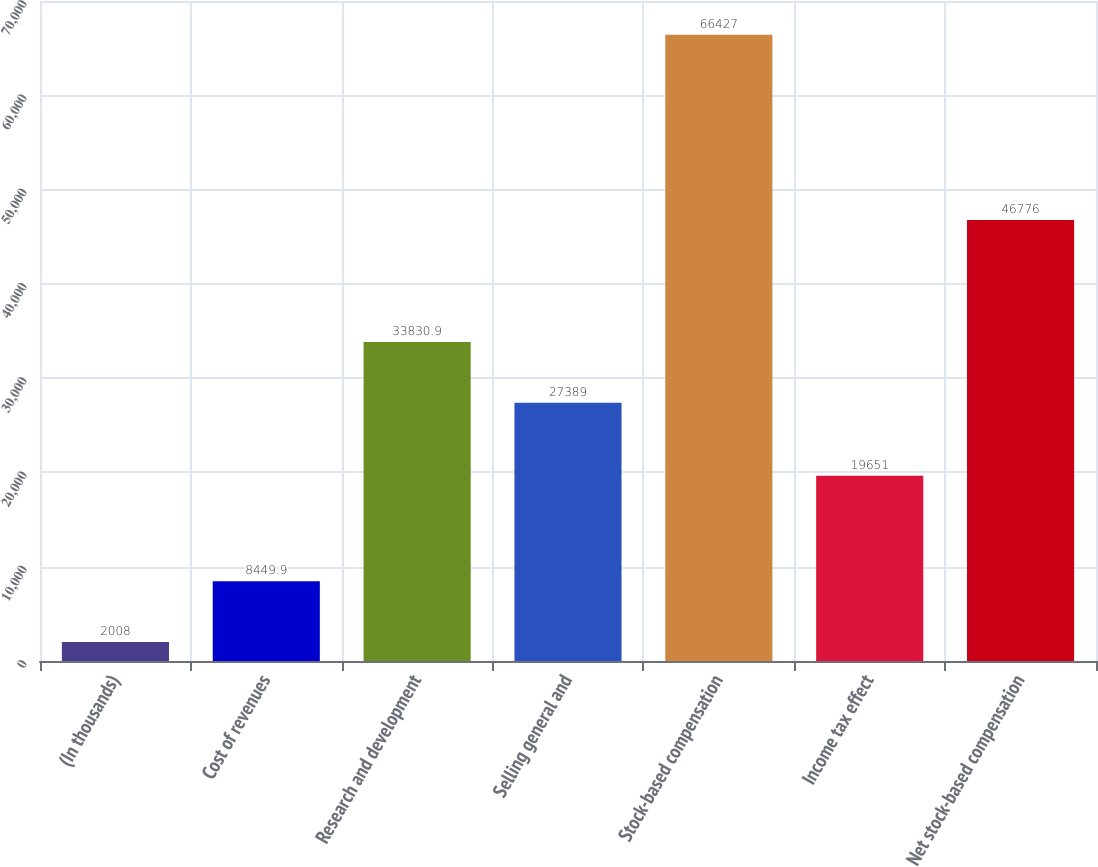<chart> <loc_0><loc_0><loc_500><loc_500><bar_chart><fcel>(In thousands)<fcel>Cost of revenues<fcel>Research and development<fcel>Selling general and<fcel>Stock-based compensation<fcel>Income tax effect<fcel>Net stock-based compensation<nl><fcel>2008<fcel>8449.9<fcel>33830.9<fcel>27389<fcel>66427<fcel>19651<fcel>46776<nl></chart> 